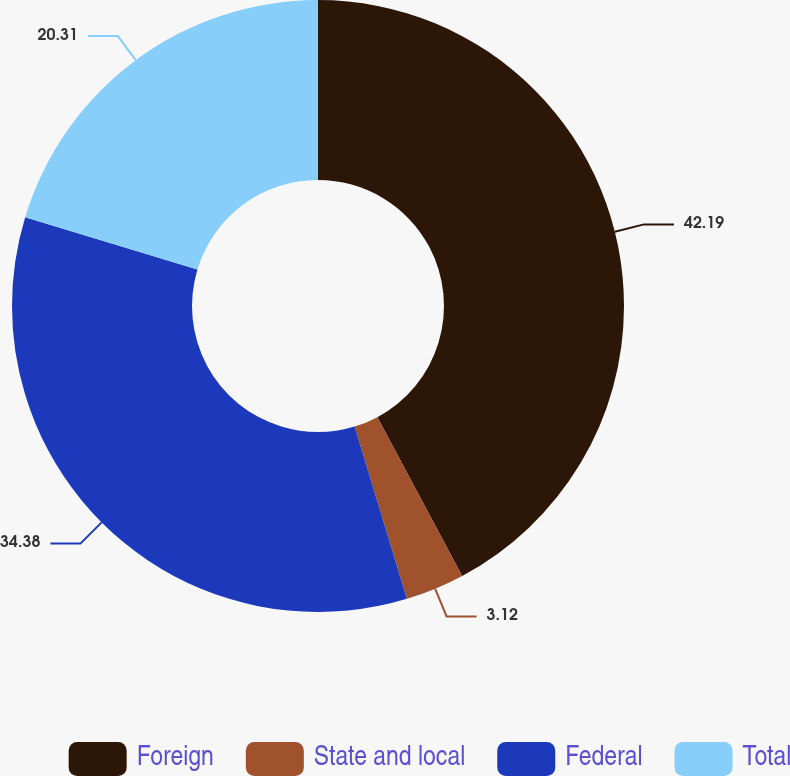Convert chart. <chart><loc_0><loc_0><loc_500><loc_500><pie_chart><fcel>Foreign<fcel>State and local<fcel>Federal<fcel>Total<nl><fcel>42.19%<fcel>3.12%<fcel>34.38%<fcel>20.31%<nl></chart> 